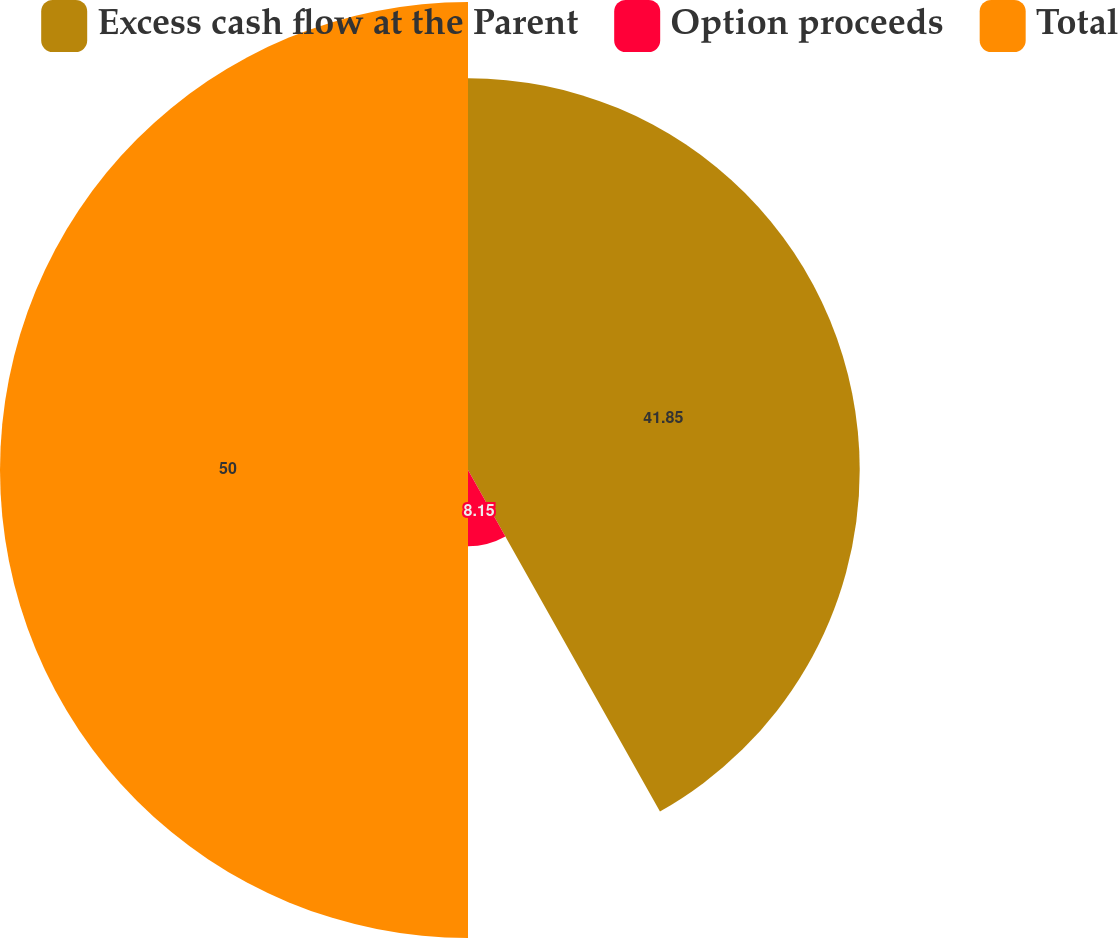Convert chart to OTSL. <chart><loc_0><loc_0><loc_500><loc_500><pie_chart><fcel>Excess cash flow at the Parent<fcel>Option proceeds<fcel>Total<nl><fcel>41.85%<fcel>8.15%<fcel>50.0%<nl></chart> 